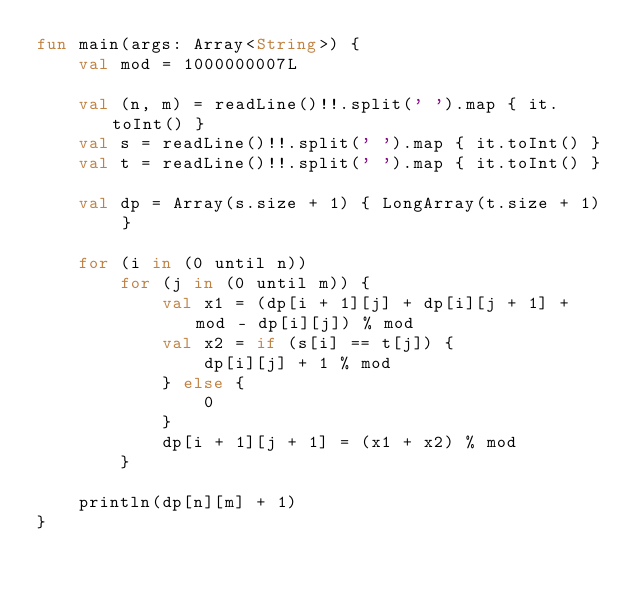<code> <loc_0><loc_0><loc_500><loc_500><_Kotlin_>fun main(args: Array<String>) {
    val mod = 1000000007L

    val (n, m) = readLine()!!.split(' ').map { it.toInt() }
    val s = readLine()!!.split(' ').map { it.toInt() }
    val t = readLine()!!.split(' ').map { it.toInt() }

    val dp = Array(s.size + 1) { LongArray(t.size + 1) }

    for (i in (0 until n))
        for (j in (0 until m)) {
            val x1 = (dp[i + 1][j] + dp[i][j + 1] + mod - dp[i][j]) % mod
            val x2 = if (s[i] == t[j]) {
                dp[i][j] + 1 % mod
            } else {
                0
            }
            dp[i + 1][j + 1] = (x1 + x2) % mod
        }

    println(dp[n][m] + 1)
}
</code> 